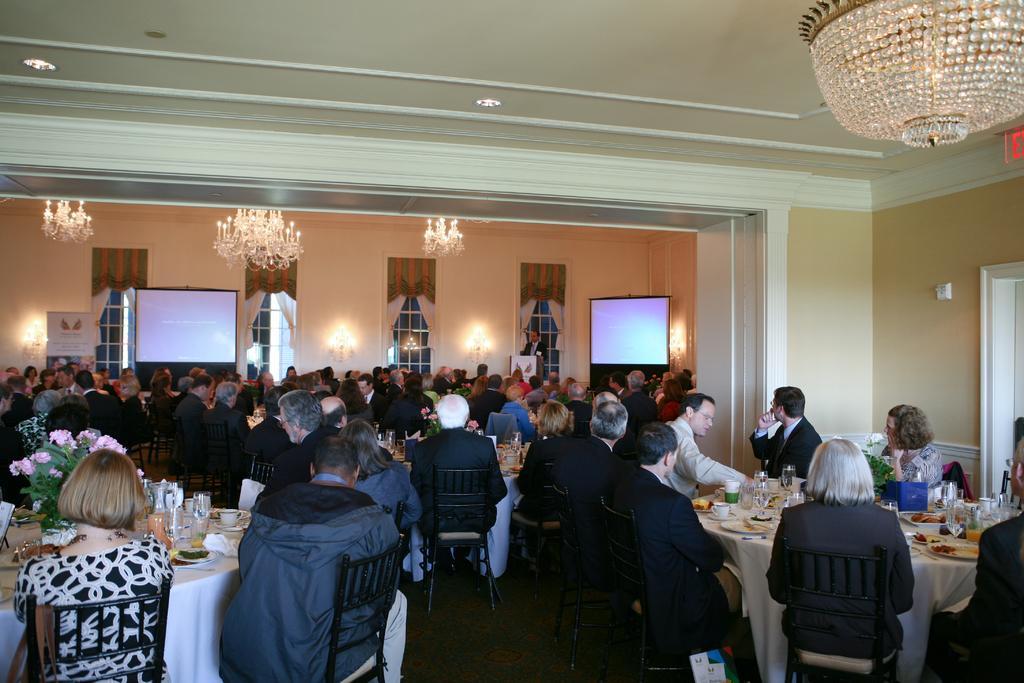How would you summarize this image in a sentence or two? In this picture there are many people sitting on a chair. In front of them there are tables. On the table there is a flower vase, glass, plates and a white color cloth on it. In the background there are four windows with white color curtains. And there are two screens. In the corner there is man in front of the podium is standing. 